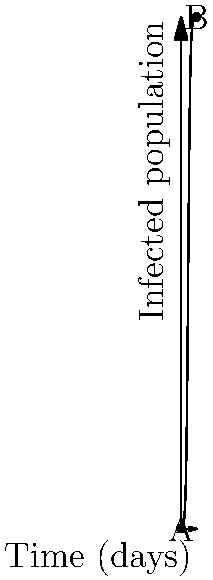In a refugee camp, a vector-borne disease is spreading according to the logistic growth model shown in the graph. The disease spreads from an initial infected population of 1 to 941 over 30 days. Calculate the daily growth rate (r) of the infected population, assuming the carrying capacity (K) is 1000. To solve this problem, we'll use the logistic growth model equation and the given information:

1) The logistic growth model is given by:
   $$ P(t) = \frac{K}{1 + (\frac{K}{P_0} - 1)e^{-rt}} $$
   where K is the carrying capacity, $P_0$ is the initial population, r is the growth rate, and t is time.

2) We're given:
   K = 1000 (carrying capacity)
   $P_0$ = 1 (initial infected population)
   P(30) = 941 (infected population after 30 days)
   t = 30 days

3) Substituting these values into the equation:
   $$ 941 = \frac{1000}{1 + (\frac{1000}{1} - 1)e^{-30r}} $$

4) Simplify:
   $$ 941 = \frac{1000}{1 + 999e^{-30r}} $$

5) Solve for $e^{-30r}$:
   $$ \frac{941}{1000} = \frac{1}{1 + 999e^{-30r}} $$
   $$ 1 + 999e^{-30r} = \frac{1000}{941} $$
   $$ 999e^{-30r} = \frac{1000}{941} - 1 $$
   $$ e^{-30r} = \frac{59}{941 \times 999} $$

6) Take natural log of both sides:
   $$ -30r = \ln(\frac{59}{941 \times 999}) $$

7) Solve for r:
   $$ r = -\frac{1}{30} \ln(\frac{59}{941 \times 999}) \approx 0.5 $$

Therefore, the daily growth rate is approximately 0.5 or 50%.
Answer: 0.5 